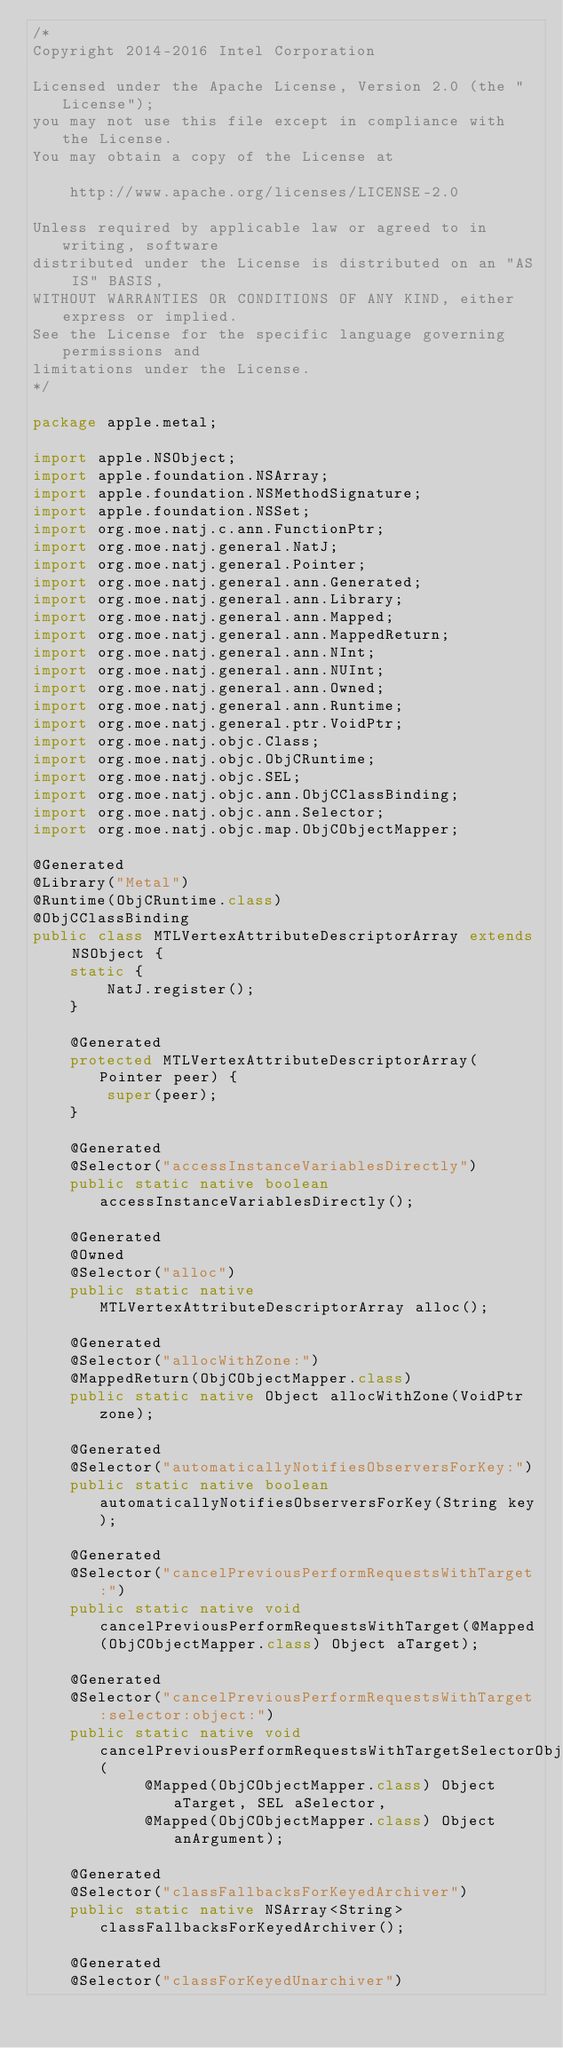<code> <loc_0><loc_0><loc_500><loc_500><_Java_>/*
Copyright 2014-2016 Intel Corporation

Licensed under the Apache License, Version 2.0 (the "License");
you may not use this file except in compliance with the License.
You may obtain a copy of the License at

    http://www.apache.org/licenses/LICENSE-2.0

Unless required by applicable law or agreed to in writing, software
distributed under the License is distributed on an "AS IS" BASIS,
WITHOUT WARRANTIES OR CONDITIONS OF ANY KIND, either express or implied.
See the License for the specific language governing permissions and
limitations under the License.
*/

package apple.metal;

import apple.NSObject;
import apple.foundation.NSArray;
import apple.foundation.NSMethodSignature;
import apple.foundation.NSSet;
import org.moe.natj.c.ann.FunctionPtr;
import org.moe.natj.general.NatJ;
import org.moe.natj.general.Pointer;
import org.moe.natj.general.ann.Generated;
import org.moe.natj.general.ann.Library;
import org.moe.natj.general.ann.Mapped;
import org.moe.natj.general.ann.MappedReturn;
import org.moe.natj.general.ann.NInt;
import org.moe.natj.general.ann.NUInt;
import org.moe.natj.general.ann.Owned;
import org.moe.natj.general.ann.Runtime;
import org.moe.natj.general.ptr.VoidPtr;
import org.moe.natj.objc.Class;
import org.moe.natj.objc.ObjCRuntime;
import org.moe.natj.objc.SEL;
import org.moe.natj.objc.ann.ObjCClassBinding;
import org.moe.natj.objc.ann.Selector;
import org.moe.natj.objc.map.ObjCObjectMapper;

@Generated
@Library("Metal")
@Runtime(ObjCRuntime.class)
@ObjCClassBinding
public class MTLVertexAttributeDescriptorArray extends NSObject {
    static {
        NatJ.register();
    }

    @Generated
    protected MTLVertexAttributeDescriptorArray(Pointer peer) {
        super(peer);
    }

    @Generated
    @Selector("accessInstanceVariablesDirectly")
    public static native boolean accessInstanceVariablesDirectly();

    @Generated
    @Owned
    @Selector("alloc")
    public static native MTLVertexAttributeDescriptorArray alloc();

    @Generated
    @Selector("allocWithZone:")
    @MappedReturn(ObjCObjectMapper.class)
    public static native Object allocWithZone(VoidPtr zone);

    @Generated
    @Selector("automaticallyNotifiesObserversForKey:")
    public static native boolean automaticallyNotifiesObserversForKey(String key);

    @Generated
    @Selector("cancelPreviousPerformRequestsWithTarget:")
    public static native void cancelPreviousPerformRequestsWithTarget(@Mapped(ObjCObjectMapper.class) Object aTarget);

    @Generated
    @Selector("cancelPreviousPerformRequestsWithTarget:selector:object:")
    public static native void cancelPreviousPerformRequestsWithTargetSelectorObject(
            @Mapped(ObjCObjectMapper.class) Object aTarget, SEL aSelector,
            @Mapped(ObjCObjectMapper.class) Object anArgument);

    @Generated
    @Selector("classFallbacksForKeyedArchiver")
    public static native NSArray<String> classFallbacksForKeyedArchiver();

    @Generated
    @Selector("classForKeyedUnarchiver")</code> 